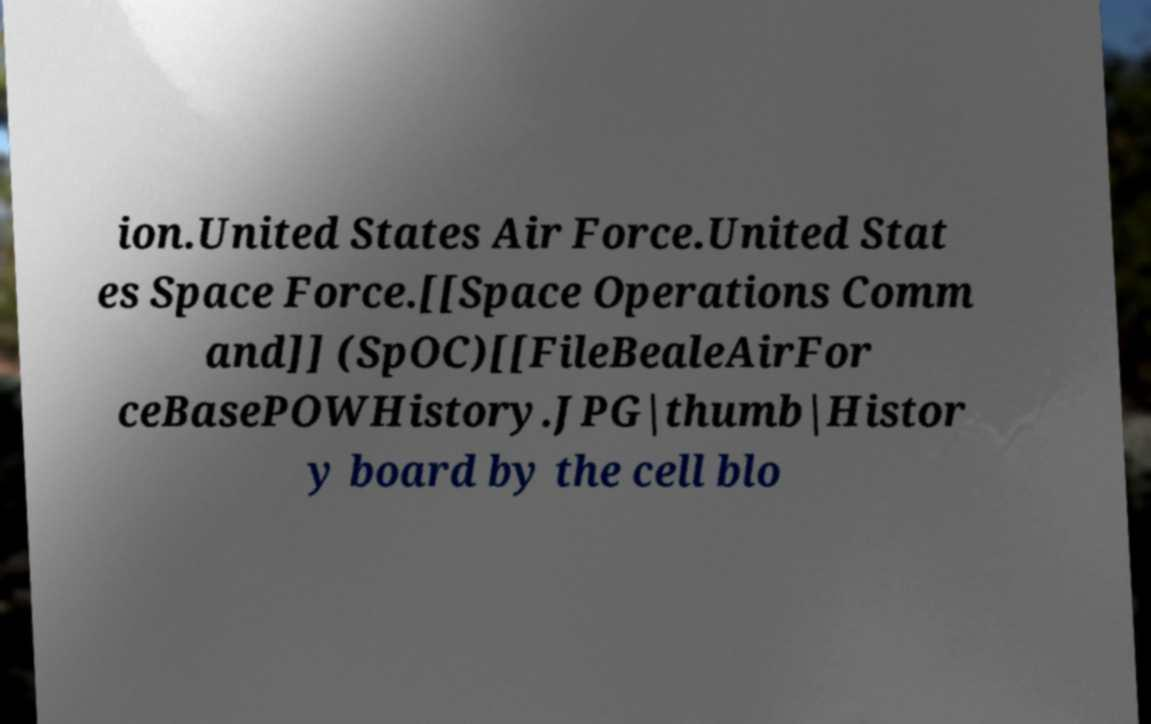Could you assist in decoding the text presented in this image and type it out clearly? ion.United States Air Force.United Stat es Space Force.[[Space Operations Comm and]] (SpOC)[[FileBealeAirFor ceBasePOWHistory.JPG|thumb|Histor y board by the cell blo 